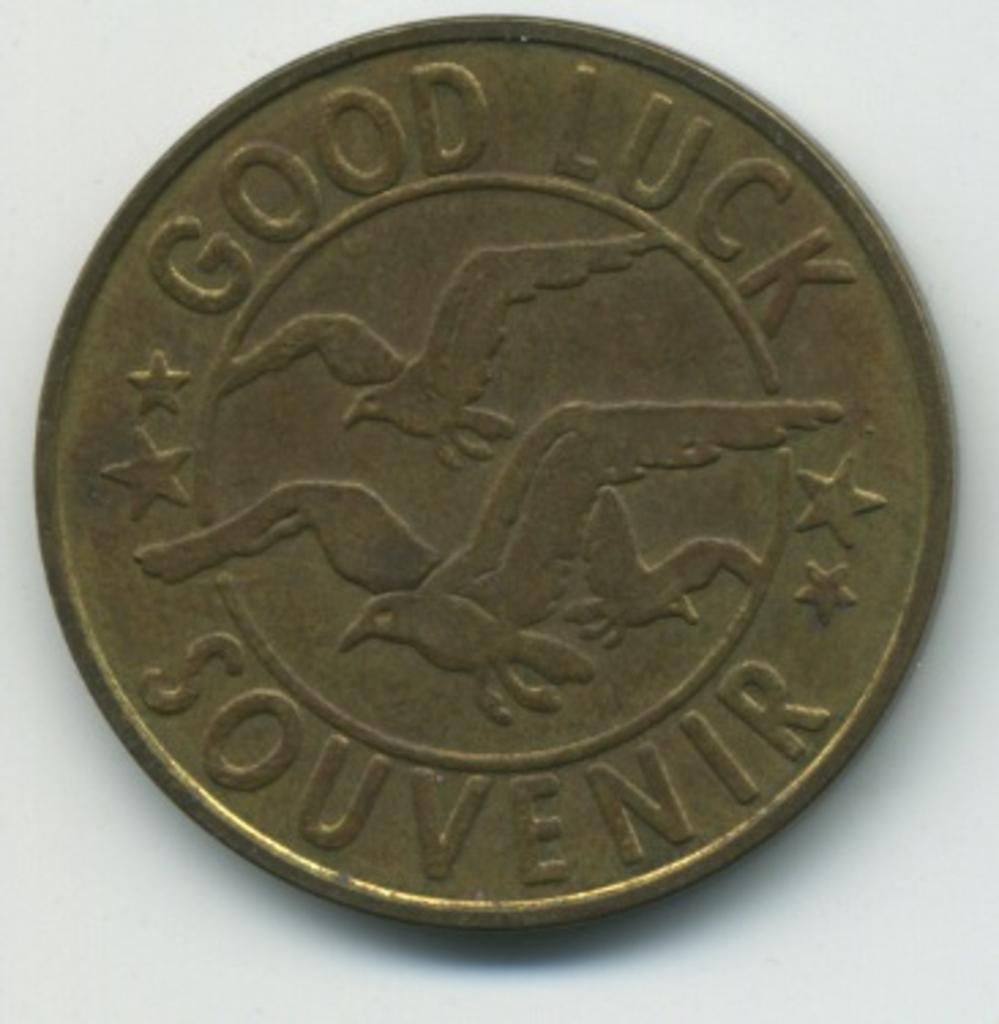<image>
Render a clear and concise summary of the photo. A coin has seagulls on it and says that it is a good luck souvenir. 